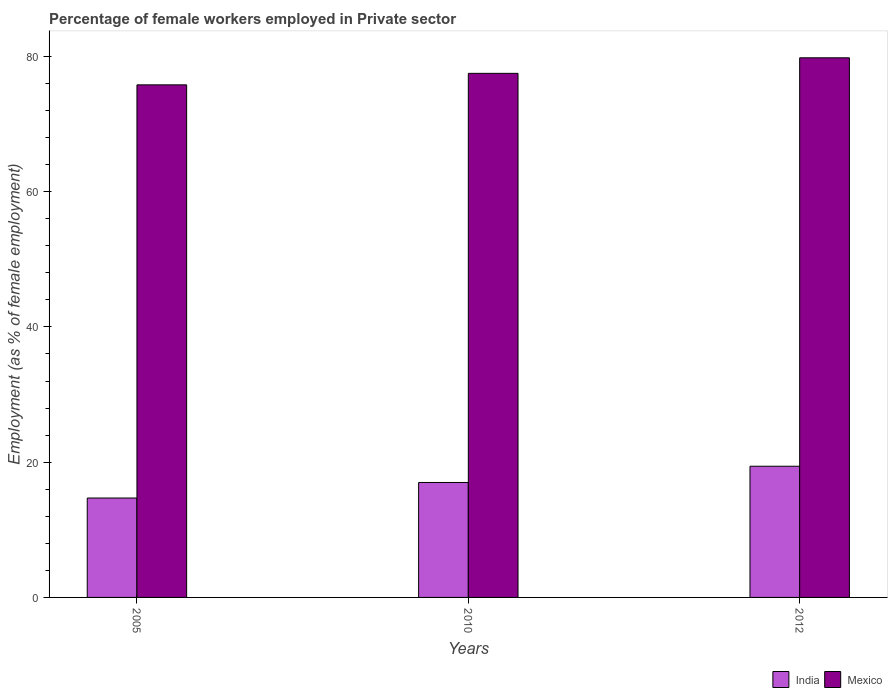Are the number of bars on each tick of the X-axis equal?
Your answer should be compact. Yes. How many bars are there on the 1st tick from the right?
Provide a short and direct response. 2. Across all years, what is the maximum percentage of females employed in Private sector in India?
Keep it short and to the point. 19.4. Across all years, what is the minimum percentage of females employed in Private sector in Mexico?
Make the answer very short. 75.8. In which year was the percentage of females employed in Private sector in Mexico minimum?
Give a very brief answer. 2005. What is the total percentage of females employed in Private sector in Mexico in the graph?
Provide a succinct answer. 233.1. What is the difference between the percentage of females employed in Private sector in Mexico in 2005 and that in 2010?
Ensure brevity in your answer.  -1.7. What is the difference between the percentage of females employed in Private sector in India in 2010 and the percentage of females employed in Private sector in Mexico in 2012?
Your answer should be very brief. -62.8. What is the average percentage of females employed in Private sector in Mexico per year?
Your answer should be compact. 77.7. In the year 2005, what is the difference between the percentage of females employed in Private sector in Mexico and percentage of females employed in Private sector in India?
Provide a short and direct response. 61.1. In how many years, is the percentage of females employed in Private sector in India greater than 20 %?
Your answer should be very brief. 0. What is the ratio of the percentage of females employed in Private sector in Mexico in 2010 to that in 2012?
Your answer should be very brief. 0.97. What is the difference between the highest and the second highest percentage of females employed in Private sector in India?
Give a very brief answer. 2.4. In how many years, is the percentage of females employed in Private sector in Mexico greater than the average percentage of females employed in Private sector in Mexico taken over all years?
Give a very brief answer. 1. Is the sum of the percentage of females employed in Private sector in Mexico in 2005 and 2010 greater than the maximum percentage of females employed in Private sector in India across all years?
Provide a succinct answer. Yes. What does the 2nd bar from the left in 2005 represents?
Offer a very short reply. Mexico. What does the 1st bar from the right in 2012 represents?
Your answer should be very brief. Mexico. How many bars are there?
Offer a terse response. 6. Are all the bars in the graph horizontal?
Offer a very short reply. No. Does the graph contain any zero values?
Your answer should be compact. No. How many legend labels are there?
Provide a succinct answer. 2. What is the title of the graph?
Provide a succinct answer. Percentage of female workers employed in Private sector. What is the label or title of the X-axis?
Provide a short and direct response. Years. What is the label or title of the Y-axis?
Keep it short and to the point. Employment (as % of female employment). What is the Employment (as % of female employment) of India in 2005?
Ensure brevity in your answer.  14.7. What is the Employment (as % of female employment) of Mexico in 2005?
Give a very brief answer. 75.8. What is the Employment (as % of female employment) of Mexico in 2010?
Keep it short and to the point. 77.5. What is the Employment (as % of female employment) in India in 2012?
Make the answer very short. 19.4. What is the Employment (as % of female employment) in Mexico in 2012?
Ensure brevity in your answer.  79.8. Across all years, what is the maximum Employment (as % of female employment) of India?
Your response must be concise. 19.4. Across all years, what is the maximum Employment (as % of female employment) in Mexico?
Make the answer very short. 79.8. Across all years, what is the minimum Employment (as % of female employment) of India?
Your answer should be compact. 14.7. Across all years, what is the minimum Employment (as % of female employment) of Mexico?
Offer a terse response. 75.8. What is the total Employment (as % of female employment) in India in the graph?
Your answer should be very brief. 51.1. What is the total Employment (as % of female employment) in Mexico in the graph?
Your response must be concise. 233.1. What is the difference between the Employment (as % of female employment) in Mexico in 2005 and that in 2012?
Offer a terse response. -4. What is the difference between the Employment (as % of female employment) of Mexico in 2010 and that in 2012?
Keep it short and to the point. -2.3. What is the difference between the Employment (as % of female employment) in India in 2005 and the Employment (as % of female employment) in Mexico in 2010?
Keep it short and to the point. -62.8. What is the difference between the Employment (as % of female employment) in India in 2005 and the Employment (as % of female employment) in Mexico in 2012?
Your answer should be very brief. -65.1. What is the difference between the Employment (as % of female employment) in India in 2010 and the Employment (as % of female employment) in Mexico in 2012?
Offer a very short reply. -62.8. What is the average Employment (as % of female employment) in India per year?
Your response must be concise. 17.03. What is the average Employment (as % of female employment) in Mexico per year?
Provide a succinct answer. 77.7. In the year 2005, what is the difference between the Employment (as % of female employment) in India and Employment (as % of female employment) in Mexico?
Ensure brevity in your answer.  -61.1. In the year 2010, what is the difference between the Employment (as % of female employment) of India and Employment (as % of female employment) of Mexico?
Keep it short and to the point. -60.5. In the year 2012, what is the difference between the Employment (as % of female employment) of India and Employment (as % of female employment) of Mexico?
Offer a very short reply. -60.4. What is the ratio of the Employment (as % of female employment) of India in 2005 to that in 2010?
Offer a terse response. 0.86. What is the ratio of the Employment (as % of female employment) of Mexico in 2005 to that in 2010?
Your answer should be very brief. 0.98. What is the ratio of the Employment (as % of female employment) in India in 2005 to that in 2012?
Your answer should be compact. 0.76. What is the ratio of the Employment (as % of female employment) in Mexico in 2005 to that in 2012?
Give a very brief answer. 0.95. What is the ratio of the Employment (as % of female employment) in India in 2010 to that in 2012?
Provide a succinct answer. 0.88. What is the ratio of the Employment (as % of female employment) of Mexico in 2010 to that in 2012?
Keep it short and to the point. 0.97. What is the difference between the highest and the second highest Employment (as % of female employment) in Mexico?
Your answer should be very brief. 2.3. What is the difference between the highest and the lowest Employment (as % of female employment) in Mexico?
Make the answer very short. 4. 